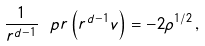Convert formula to latex. <formula><loc_0><loc_0><loc_500><loc_500>\frac { 1 } { r ^ { d - 1 } } \ p { r } \left ( r ^ { d - 1 } v \right ) = - 2 \rho ^ { 1 / 2 } \, ,</formula> 